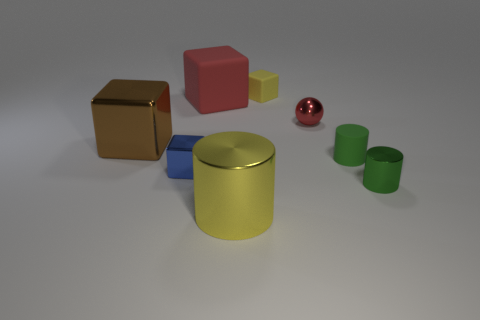Is there any other thing that has the same shape as the yellow matte object? Yes, the red object to the right of the yellow one appears to have a similar spherical shape. 